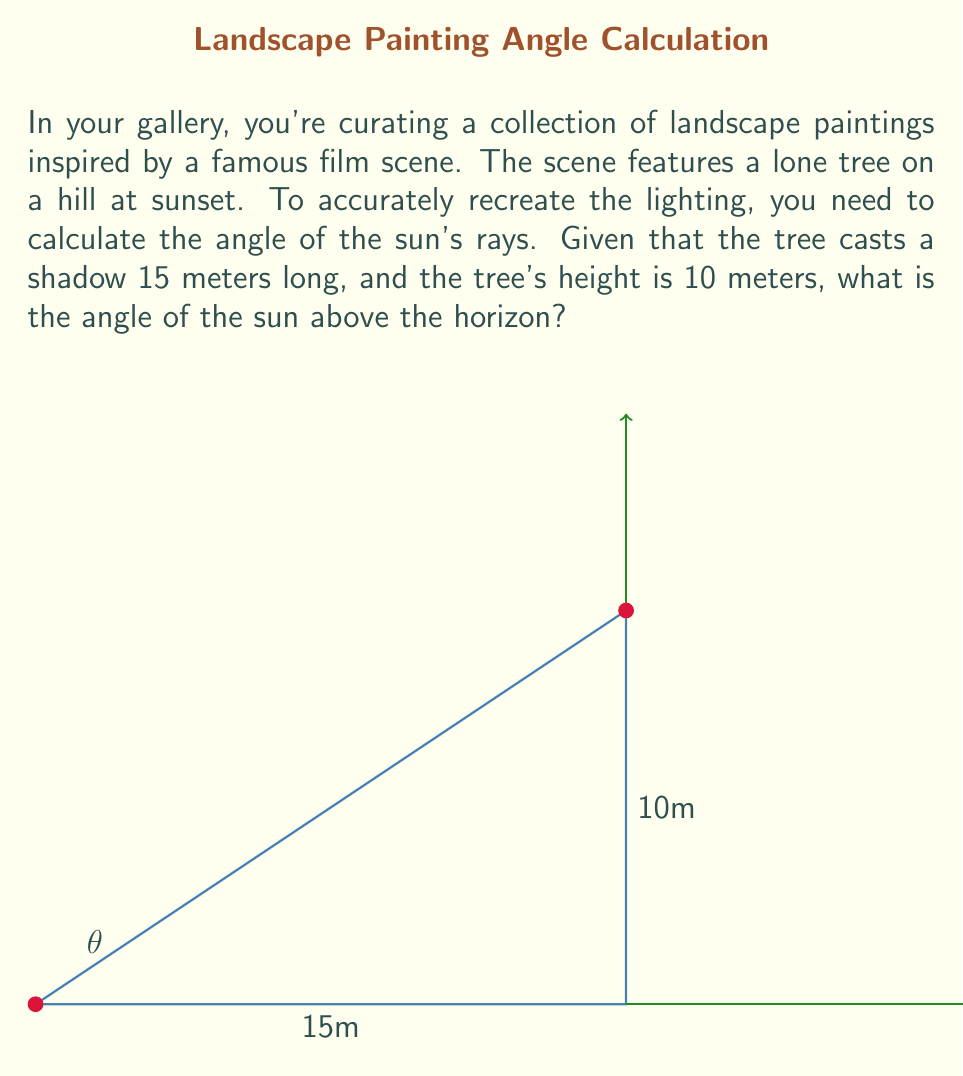Solve this math problem. To solve this problem, we'll use trigonometry, specifically the tangent function. Here's the step-by-step solution:

1) In a right triangle formed by the tree, its shadow, and the sun's rays, we have:
   - The adjacent side (shadow length) = 15 meters
   - The opposite side (tree height) = 10 meters
   - The angle we're looking for is between the ground and the sun's rays

2) The tangent of an angle in a right triangle is defined as the ratio of the opposite side to the adjacent side:

   $$\tan(\theta) = \frac{\text{opposite}}{\text{adjacent}}$$

3) Substituting our values:

   $$\tan(\theta) = \frac{10}{15}$$

4) To find the angle $\theta$, we need to take the inverse tangent (arctan or $\tan^{-1}$) of both sides:

   $$\theta = \tan^{-1}(\frac{10}{15})$$

5) Using a calculator or computer:

   $$\theta \approx 33.69°$$

6) Round to two decimal places:

   $$\theta \approx 33.69°$$

This angle represents the elevation of the sun above the horizon in the scene.
Answer: $33.69°$ 